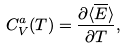Convert formula to latex. <formula><loc_0><loc_0><loc_500><loc_500>C _ { V } ^ { a } ( T ) = \frac { \partial \langle \overline { E } \rangle } { \partial T } ,</formula> 